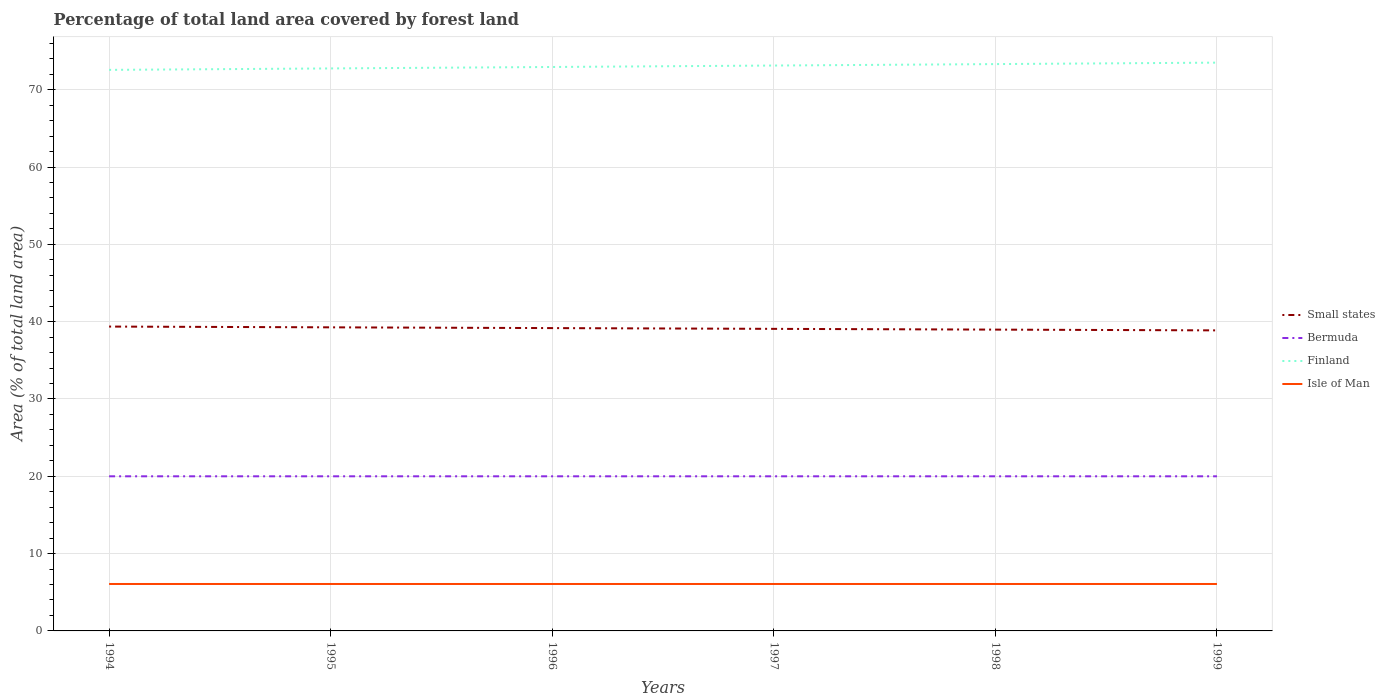How many different coloured lines are there?
Provide a short and direct response. 4. Across all years, what is the maximum percentage of forest land in Finland?
Your answer should be very brief. 72.57. What is the total percentage of forest land in Small states in the graph?
Offer a terse response. 0.1. What is the difference between the highest and the second highest percentage of forest land in Small states?
Provide a succinct answer. 0.49. Is the percentage of forest land in Small states strictly greater than the percentage of forest land in Bermuda over the years?
Make the answer very short. No. Are the values on the major ticks of Y-axis written in scientific E-notation?
Keep it short and to the point. No. Does the graph contain any zero values?
Make the answer very short. No. Does the graph contain grids?
Keep it short and to the point. Yes. Where does the legend appear in the graph?
Ensure brevity in your answer.  Center right. What is the title of the graph?
Your response must be concise. Percentage of total land area covered by forest land. Does "Guam" appear as one of the legend labels in the graph?
Offer a very short reply. No. What is the label or title of the Y-axis?
Offer a very short reply. Area (% of total land area). What is the Area (% of total land area) of Small states in 1994?
Your answer should be very brief. 39.37. What is the Area (% of total land area) in Bermuda in 1994?
Offer a terse response. 20. What is the Area (% of total land area) in Finland in 1994?
Ensure brevity in your answer.  72.57. What is the Area (% of total land area) in Isle of Man in 1994?
Your answer should be compact. 6.07. What is the Area (% of total land area) of Small states in 1995?
Ensure brevity in your answer.  39.27. What is the Area (% of total land area) of Finland in 1995?
Provide a succinct answer. 72.75. What is the Area (% of total land area) of Isle of Man in 1995?
Provide a short and direct response. 6.07. What is the Area (% of total land area) of Small states in 1996?
Make the answer very short. 39.17. What is the Area (% of total land area) of Bermuda in 1996?
Offer a terse response. 20. What is the Area (% of total land area) in Finland in 1996?
Your response must be concise. 72.94. What is the Area (% of total land area) of Isle of Man in 1996?
Give a very brief answer. 6.07. What is the Area (% of total land area) in Small states in 1997?
Provide a short and direct response. 39.07. What is the Area (% of total land area) of Finland in 1997?
Give a very brief answer. 73.13. What is the Area (% of total land area) in Isle of Man in 1997?
Offer a terse response. 6.07. What is the Area (% of total land area) of Small states in 1998?
Your answer should be compact. 38.97. What is the Area (% of total land area) of Bermuda in 1998?
Your answer should be compact. 20. What is the Area (% of total land area) in Finland in 1998?
Provide a short and direct response. 73.31. What is the Area (% of total land area) of Isle of Man in 1998?
Keep it short and to the point. 6.07. What is the Area (% of total land area) in Small states in 1999?
Your answer should be very brief. 38.87. What is the Area (% of total land area) of Finland in 1999?
Offer a terse response. 73.5. What is the Area (% of total land area) in Isle of Man in 1999?
Your answer should be compact. 6.07. Across all years, what is the maximum Area (% of total land area) in Small states?
Make the answer very short. 39.37. Across all years, what is the maximum Area (% of total land area) in Finland?
Make the answer very short. 73.5. Across all years, what is the maximum Area (% of total land area) of Isle of Man?
Give a very brief answer. 6.07. Across all years, what is the minimum Area (% of total land area) in Small states?
Provide a succinct answer. 38.87. Across all years, what is the minimum Area (% of total land area) in Finland?
Your answer should be very brief. 72.57. Across all years, what is the minimum Area (% of total land area) of Isle of Man?
Provide a short and direct response. 6.07. What is the total Area (% of total land area) of Small states in the graph?
Offer a terse response. 234.72. What is the total Area (% of total land area) of Bermuda in the graph?
Provide a succinct answer. 120. What is the total Area (% of total land area) of Finland in the graph?
Your answer should be very brief. 438.21. What is the total Area (% of total land area) of Isle of Man in the graph?
Keep it short and to the point. 36.42. What is the difference between the Area (% of total land area) of Small states in 1994 and that in 1995?
Provide a short and direct response. 0.1. What is the difference between the Area (% of total land area) of Bermuda in 1994 and that in 1995?
Offer a terse response. 0. What is the difference between the Area (% of total land area) in Finland in 1994 and that in 1995?
Give a very brief answer. -0.19. What is the difference between the Area (% of total land area) of Isle of Man in 1994 and that in 1995?
Give a very brief answer. 0. What is the difference between the Area (% of total land area) of Small states in 1994 and that in 1996?
Provide a succinct answer. 0.2. What is the difference between the Area (% of total land area) in Bermuda in 1994 and that in 1996?
Provide a short and direct response. 0. What is the difference between the Area (% of total land area) of Finland in 1994 and that in 1996?
Make the answer very short. -0.37. What is the difference between the Area (% of total land area) in Small states in 1994 and that in 1997?
Your response must be concise. 0.3. What is the difference between the Area (% of total land area) in Finland in 1994 and that in 1997?
Your answer should be compact. -0.56. What is the difference between the Area (% of total land area) in Small states in 1994 and that in 1998?
Your answer should be very brief. 0.39. What is the difference between the Area (% of total land area) of Bermuda in 1994 and that in 1998?
Offer a terse response. 0. What is the difference between the Area (% of total land area) of Finland in 1994 and that in 1998?
Keep it short and to the point. -0.75. What is the difference between the Area (% of total land area) in Small states in 1994 and that in 1999?
Your answer should be very brief. 0.49. What is the difference between the Area (% of total land area) of Finland in 1994 and that in 1999?
Your answer should be very brief. -0.94. What is the difference between the Area (% of total land area) in Isle of Man in 1994 and that in 1999?
Keep it short and to the point. 0. What is the difference between the Area (% of total land area) in Small states in 1995 and that in 1996?
Provide a succinct answer. 0.1. What is the difference between the Area (% of total land area) of Bermuda in 1995 and that in 1996?
Offer a very short reply. 0. What is the difference between the Area (% of total land area) of Finland in 1995 and that in 1996?
Ensure brevity in your answer.  -0.19. What is the difference between the Area (% of total land area) of Small states in 1995 and that in 1997?
Ensure brevity in your answer.  0.2. What is the difference between the Area (% of total land area) of Bermuda in 1995 and that in 1997?
Your answer should be very brief. 0. What is the difference between the Area (% of total land area) in Finland in 1995 and that in 1997?
Offer a very short reply. -0.37. What is the difference between the Area (% of total land area) in Isle of Man in 1995 and that in 1997?
Your response must be concise. 0. What is the difference between the Area (% of total land area) in Small states in 1995 and that in 1998?
Keep it short and to the point. 0.3. What is the difference between the Area (% of total land area) in Finland in 1995 and that in 1998?
Keep it short and to the point. -0.56. What is the difference between the Area (% of total land area) of Small states in 1995 and that in 1999?
Ensure brevity in your answer.  0.39. What is the difference between the Area (% of total land area) of Bermuda in 1995 and that in 1999?
Offer a very short reply. 0. What is the difference between the Area (% of total land area) of Finland in 1995 and that in 1999?
Your response must be concise. -0.75. What is the difference between the Area (% of total land area) of Small states in 1996 and that in 1997?
Provide a succinct answer. 0.1. What is the difference between the Area (% of total land area) of Finland in 1996 and that in 1997?
Provide a short and direct response. -0.19. What is the difference between the Area (% of total land area) in Isle of Man in 1996 and that in 1997?
Provide a succinct answer. 0. What is the difference between the Area (% of total land area) in Small states in 1996 and that in 1998?
Your answer should be compact. 0.2. What is the difference between the Area (% of total land area) in Finland in 1996 and that in 1998?
Provide a short and direct response. -0.37. What is the difference between the Area (% of total land area) of Isle of Man in 1996 and that in 1998?
Make the answer very short. 0. What is the difference between the Area (% of total land area) of Small states in 1996 and that in 1999?
Provide a succinct answer. 0.3. What is the difference between the Area (% of total land area) in Finland in 1996 and that in 1999?
Provide a succinct answer. -0.56. What is the difference between the Area (% of total land area) of Small states in 1997 and that in 1998?
Your answer should be compact. 0.1. What is the difference between the Area (% of total land area) in Bermuda in 1997 and that in 1998?
Your answer should be compact. 0. What is the difference between the Area (% of total land area) in Finland in 1997 and that in 1998?
Ensure brevity in your answer.  -0.19. What is the difference between the Area (% of total land area) of Isle of Man in 1997 and that in 1998?
Provide a short and direct response. 0. What is the difference between the Area (% of total land area) of Small states in 1997 and that in 1999?
Keep it short and to the point. 0.2. What is the difference between the Area (% of total land area) in Finland in 1997 and that in 1999?
Give a very brief answer. -0.37. What is the difference between the Area (% of total land area) in Small states in 1998 and that in 1999?
Your response must be concise. 0.1. What is the difference between the Area (% of total land area) of Bermuda in 1998 and that in 1999?
Offer a terse response. 0. What is the difference between the Area (% of total land area) in Finland in 1998 and that in 1999?
Offer a very short reply. -0.19. What is the difference between the Area (% of total land area) in Isle of Man in 1998 and that in 1999?
Give a very brief answer. 0. What is the difference between the Area (% of total land area) of Small states in 1994 and the Area (% of total land area) of Bermuda in 1995?
Give a very brief answer. 19.37. What is the difference between the Area (% of total land area) of Small states in 1994 and the Area (% of total land area) of Finland in 1995?
Keep it short and to the point. -33.39. What is the difference between the Area (% of total land area) of Small states in 1994 and the Area (% of total land area) of Isle of Man in 1995?
Provide a short and direct response. 33.3. What is the difference between the Area (% of total land area) of Bermuda in 1994 and the Area (% of total land area) of Finland in 1995?
Your response must be concise. -52.75. What is the difference between the Area (% of total land area) of Bermuda in 1994 and the Area (% of total land area) of Isle of Man in 1995?
Ensure brevity in your answer.  13.93. What is the difference between the Area (% of total land area) of Finland in 1994 and the Area (% of total land area) of Isle of Man in 1995?
Provide a short and direct response. 66.5. What is the difference between the Area (% of total land area) of Small states in 1994 and the Area (% of total land area) of Bermuda in 1996?
Provide a succinct answer. 19.37. What is the difference between the Area (% of total land area) of Small states in 1994 and the Area (% of total land area) of Finland in 1996?
Offer a very short reply. -33.58. What is the difference between the Area (% of total land area) in Small states in 1994 and the Area (% of total land area) in Isle of Man in 1996?
Give a very brief answer. 33.3. What is the difference between the Area (% of total land area) of Bermuda in 1994 and the Area (% of total land area) of Finland in 1996?
Provide a succinct answer. -52.94. What is the difference between the Area (% of total land area) in Bermuda in 1994 and the Area (% of total land area) in Isle of Man in 1996?
Offer a terse response. 13.93. What is the difference between the Area (% of total land area) of Finland in 1994 and the Area (% of total land area) of Isle of Man in 1996?
Provide a short and direct response. 66.5. What is the difference between the Area (% of total land area) of Small states in 1994 and the Area (% of total land area) of Bermuda in 1997?
Offer a very short reply. 19.37. What is the difference between the Area (% of total land area) in Small states in 1994 and the Area (% of total land area) in Finland in 1997?
Provide a short and direct response. -33.76. What is the difference between the Area (% of total land area) in Small states in 1994 and the Area (% of total land area) in Isle of Man in 1997?
Provide a succinct answer. 33.3. What is the difference between the Area (% of total land area) of Bermuda in 1994 and the Area (% of total land area) of Finland in 1997?
Make the answer very short. -53.13. What is the difference between the Area (% of total land area) in Bermuda in 1994 and the Area (% of total land area) in Isle of Man in 1997?
Make the answer very short. 13.93. What is the difference between the Area (% of total land area) of Finland in 1994 and the Area (% of total land area) of Isle of Man in 1997?
Provide a succinct answer. 66.5. What is the difference between the Area (% of total land area) in Small states in 1994 and the Area (% of total land area) in Bermuda in 1998?
Your answer should be very brief. 19.37. What is the difference between the Area (% of total land area) of Small states in 1994 and the Area (% of total land area) of Finland in 1998?
Your answer should be very brief. -33.95. What is the difference between the Area (% of total land area) in Small states in 1994 and the Area (% of total land area) in Isle of Man in 1998?
Make the answer very short. 33.3. What is the difference between the Area (% of total land area) in Bermuda in 1994 and the Area (% of total land area) in Finland in 1998?
Offer a terse response. -53.31. What is the difference between the Area (% of total land area) in Bermuda in 1994 and the Area (% of total land area) in Isle of Man in 1998?
Your response must be concise. 13.93. What is the difference between the Area (% of total land area) of Finland in 1994 and the Area (% of total land area) of Isle of Man in 1998?
Provide a short and direct response. 66.5. What is the difference between the Area (% of total land area) in Small states in 1994 and the Area (% of total land area) in Bermuda in 1999?
Make the answer very short. 19.37. What is the difference between the Area (% of total land area) of Small states in 1994 and the Area (% of total land area) of Finland in 1999?
Offer a very short reply. -34.14. What is the difference between the Area (% of total land area) of Small states in 1994 and the Area (% of total land area) of Isle of Man in 1999?
Your answer should be very brief. 33.3. What is the difference between the Area (% of total land area) in Bermuda in 1994 and the Area (% of total land area) in Finland in 1999?
Offer a terse response. -53.5. What is the difference between the Area (% of total land area) in Bermuda in 1994 and the Area (% of total land area) in Isle of Man in 1999?
Make the answer very short. 13.93. What is the difference between the Area (% of total land area) of Finland in 1994 and the Area (% of total land area) of Isle of Man in 1999?
Offer a very short reply. 66.5. What is the difference between the Area (% of total land area) in Small states in 1995 and the Area (% of total land area) in Bermuda in 1996?
Provide a succinct answer. 19.27. What is the difference between the Area (% of total land area) of Small states in 1995 and the Area (% of total land area) of Finland in 1996?
Make the answer very short. -33.67. What is the difference between the Area (% of total land area) in Small states in 1995 and the Area (% of total land area) in Isle of Man in 1996?
Your answer should be compact. 33.2. What is the difference between the Area (% of total land area) in Bermuda in 1995 and the Area (% of total land area) in Finland in 1996?
Your response must be concise. -52.94. What is the difference between the Area (% of total land area) in Bermuda in 1995 and the Area (% of total land area) in Isle of Man in 1996?
Your response must be concise. 13.93. What is the difference between the Area (% of total land area) in Finland in 1995 and the Area (% of total land area) in Isle of Man in 1996?
Make the answer very short. 66.68. What is the difference between the Area (% of total land area) in Small states in 1995 and the Area (% of total land area) in Bermuda in 1997?
Your answer should be compact. 19.27. What is the difference between the Area (% of total land area) in Small states in 1995 and the Area (% of total land area) in Finland in 1997?
Make the answer very short. -33.86. What is the difference between the Area (% of total land area) in Small states in 1995 and the Area (% of total land area) in Isle of Man in 1997?
Give a very brief answer. 33.2. What is the difference between the Area (% of total land area) of Bermuda in 1995 and the Area (% of total land area) of Finland in 1997?
Provide a short and direct response. -53.13. What is the difference between the Area (% of total land area) of Bermuda in 1995 and the Area (% of total land area) of Isle of Man in 1997?
Ensure brevity in your answer.  13.93. What is the difference between the Area (% of total land area) in Finland in 1995 and the Area (% of total land area) in Isle of Man in 1997?
Make the answer very short. 66.68. What is the difference between the Area (% of total land area) in Small states in 1995 and the Area (% of total land area) in Bermuda in 1998?
Ensure brevity in your answer.  19.27. What is the difference between the Area (% of total land area) in Small states in 1995 and the Area (% of total land area) in Finland in 1998?
Give a very brief answer. -34.05. What is the difference between the Area (% of total land area) of Small states in 1995 and the Area (% of total land area) of Isle of Man in 1998?
Provide a short and direct response. 33.2. What is the difference between the Area (% of total land area) in Bermuda in 1995 and the Area (% of total land area) in Finland in 1998?
Give a very brief answer. -53.31. What is the difference between the Area (% of total land area) of Bermuda in 1995 and the Area (% of total land area) of Isle of Man in 1998?
Keep it short and to the point. 13.93. What is the difference between the Area (% of total land area) in Finland in 1995 and the Area (% of total land area) in Isle of Man in 1998?
Your answer should be compact. 66.68. What is the difference between the Area (% of total land area) of Small states in 1995 and the Area (% of total land area) of Bermuda in 1999?
Make the answer very short. 19.27. What is the difference between the Area (% of total land area) of Small states in 1995 and the Area (% of total land area) of Finland in 1999?
Your response must be concise. -34.24. What is the difference between the Area (% of total land area) in Small states in 1995 and the Area (% of total land area) in Isle of Man in 1999?
Offer a very short reply. 33.2. What is the difference between the Area (% of total land area) of Bermuda in 1995 and the Area (% of total land area) of Finland in 1999?
Offer a terse response. -53.5. What is the difference between the Area (% of total land area) of Bermuda in 1995 and the Area (% of total land area) of Isle of Man in 1999?
Keep it short and to the point. 13.93. What is the difference between the Area (% of total land area) in Finland in 1995 and the Area (% of total land area) in Isle of Man in 1999?
Ensure brevity in your answer.  66.68. What is the difference between the Area (% of total land area) in Small states in 1996 and the Area (% of total land area) in Bermuda in 1997?
Provide a short and direct response. 19.17. What is the difference between the Area (% of total land area) in Small states in 1996 and the Area (% of total land area) in Finland in 1997?
Offer a very short reply. -33.96. What is the difference between the Area (% of total land area) of Small states in 1996 and the Area (% of total land area) of Isle of Man in 1997?
Your answer should be compact. 33.1. What is the difference between the Area (% of total land area) in Bermuda in 1996 and the Area (% of total land area) in Finland in 1997?
Offer a very short reply. -53.13. What is the difference between the Area (% of total land area) in Bermuda in 1996 and the Area (% of total land area) in Isle of Man in 1997?
Your answer should be very brief. 13.93. What is the difference between the Area (% of total land area) in Finland in 1996 and the Area (% of total land area) in Isle of Man in 1997?
Give a very brief answer. 66.87. What is the difference between the Area (% of total land area) in Small states in 1996 and the Area (% of total land area) in Bermuda in 1998?
Offer a terse response. 19.17. What is the difference between the Area (% of total land area) in Small states in 1996 and the Area (% of total land area) in Finland in 1998?
Offer a terse response. -34.15. What is the difference between the Area (% of total land area) of Small states in 1996 and the Area (% of total land area) of Isle of Man in 1998?
Your response must be concise. 33.1. What is the difference between the Area (% of total land area) of Bermuda in 1996 and the Area (% of total land area) of Finland in 1998?
Your answer should be compact. -53.31. What is the difference between the Area (% of total land area) of Bermuda in 1996 and the Area (% of total land area) of Isle of Man in 1998?
Make the answer very short. 13.93. What is the difference between the Area (% of total land area) of Finland in 1996 and the Area (% of total land area) of Isle of Man in 1998?
Ensure brevity in your answer.  66.87. What is the difference between the Area (% of total land area) in Small states in 1996 and the Area (% of total land area) in Bermuda in 1999?
Make the answer very short. 19.17. What is the difference between the Area (% of total land area) in Small states in 1996 and the Area (% of total land area) in Finland in 1999?
Offer a very short reply. -34.33. What is the difference between the Area (% of total land area) of Small states in 1996 and the Area (% of total land area) of Isle of Man in 1999?
Offer a very short reply. 33.1. What is the difference between the Area (% of total land area) in Bermuda in 1996 and the Area (% of total land area) in Finland in 1999?
Ensure brevity in your answer.  -53.5. What is the difference between the Area (% of total land area) in Bermuda in 1996 and the Area (% of total land area) in Isle of Man in 1999?
Your response must be concise. 13.93. What is the difference between the Area (% of total land area) in Finland in 1996 and the Area (% of total land area) in Isle of Man in 1999?
Your answer should be very brief. 66.87. What is the difference between the Area (% of total land area) in Small states in 1997 and the Area (% of total land area) in Bermuda in 1998?
Provide a short and direct response. 19.07. What is the difference between the Area (% of total land area) in Small states in 1997 and the Area (% of total land area) in Finland in 1998?
Give a very brief answer. -34.24. What is the difference between the Area (% of total land area) of Small states in 1997 and the Area (% of total land area) of Isle of Man in 1998?
Make the answer very short. 33. What is the difference between the Area (% of total land area) in Bermuda in 1997 and the Area (% of total land area) in Finland in 1998?
Provide a short and direct response. -53.31. What is the difference between the Area (% of total land area) in Bermuda in 1997 and the Area (% of total land area) in Isle of Man in 1998?
Your answer should be compact. 13.93. What is the difference between the Area (% of total land area) in Finland in 1997 and the Area (% of total land area) in Isle of Man in 1998?
Your answer should be compact. 67.06. What is the difference between the Area (% of total land area) of Small states in 1997 and the Area (% of total land area) of Bermuda in 1999?
Offer a very short reply. 19.07. What is the difference between the Area (% of total land area) in Small states in 1997 and the Area (% of total land area) in Finland in 1999?
Offer a terse response. -34.43. What is the difference between the Area (% of total land area) in Small states in 1997 and the Area (% of total land area) in Isle of Man in 1999?
Your answer should be very brief. 33. What is the difference between the Area (% of total land area) in Bermuda in 1997 and the Area (% of total land area) in Finland in 1999?
Your answer should be compact. -53.5. What is the difference between the Area (% of total land area) in Bermuda in 1997 and the Area (% of total land area) in Isle of Man in 1999?
Your answer should be very brief. 13.93. What is the difference between the Area (% of total land area) of Finland in 1997 and the Area (% of total land area) of Isle of Man in 1999?
Offer a very short reply. 67.06. What is the difference between the Area (% of total land area) in Small states in 1998 and the Area (% of total land area) in Bermuda in 1999?
Offer a very short reply. 18.97. What is the difference between the Area (% of total land area) in Small states in 1998 and the Area (% of total land area) in Finland in 1999?
Your answer should be very brief. -34.53. What is the difference between the Area (% of total land area) in Small states in 1998 and the Area (% of total land area) in Isle of Man in 1999?
Provide a succinct answer. 32.9. What is the difference between the Area (% of total land area) in Bermuda in 1998 and the Area (% of total land area) in Finland in 1999?
Provide a succinct answer. -53.5. What is the difference between the Area (% of total land area) of Bermuda in 1998 and the Area (% of total land area) of Isle of Man in 1999?
Keep it short and to the point. 13.93. What is the difference between the Area (% of total land area) of Finland in 1998 and the Area (% of total land area) of Isle of Man in 1999?
Your answer should be very brief. 67.24. What is the average Area (% of total land area) in Small states per year?
Ensure brevity in your answer.  39.12. What is the average Area (% of total land area) in Finland per year?
Your answer should be very brief. 73.03. What is the average Area (% of total land area) in Isle of Man per year?
Ensure brevity in your answer.  6.07. In the year 1994, what is the difference between the Area (% of total land area) in Small states and Area (% of total land area) in Bermuda?
Make the answer very short. 19.37. In the year 1994, what is the difference between the Area (% of total land area) of Small states and Area (% of total land area) of Finland?
Give a very brief answer. -33.2. In the year 1994, what is the difference between the Area (% of total land area) of Small states and Area (% of total land area) of Isle of Man?
Offer a terse response. 33.3. In the year 1994, what is the difference between the Area (% of total land area) in Bermuda and Area (% of total land area) in Finland?
Provide a short and direct response. -52.57. In the year 1994, what is the difference between the Area (% of total land area) in Bermuda and Area (% of total land area) in Isle of Man?
Provide a short and direct response. 13.93. In the year 1994, what is the difference between the Area (% of total land area) of Finland and Area (% of total land area) of Isle of Man?
Give a very brief answer. 66.5. In the year 1995, what is the difference between the Area (% of total land area) of Small states and Area (% of total land area) of Bermuda?
Your answer should be compact. 19.27. In the year 1995, what is the difference between the Area (% of total land area) in Small states and Area (% of total land area) in Finland?
Provide a succinct answer. -33.49. In the year 1995, what is the difference between the Area (% of total land area) in Small states and Area (% of total land area) in Isle of Man?
Keep it short and to the point. 33.2. In the year 1995, what is the difference between the Area (% of total land area) in Bermuda and Area (% of total land area) in Finland?
Your answer should be very brief. -52.75. In the year 1995, what is the difference between the Area (% of total land area) in Bermuda and Area (% of total land area) in Isle of Man?
Give a very brief answer. 13.93. In the year 1995, what is the difference between the Area (% of total land area) of Finland and Area (% of total land area) of Isle of Man?
Make the answer very short. 66.68. In the year 1996, what is the difference between the Area (% of total land area) of Small states and Area (% of total land area) of Bermuda?
Your answer should be very brief. 19.17. In the year 1996, what is the difference between the Area (% of total land area) in Small states and Area (% of total land area) in Finland?
Offer a very short reply. -33.77. In the year 1996, what is the difference between the Area (% of total land area) of Small states and Area (% of total land area) of Isle of Man?
Ensure brevity in your answer.  33.1. In the year 1996, what is the difference between the Area (% of total land area) of Bermuda and Area (% of total land area) of Finland?
Offer a very short reply. -52.94. In the year 1996, what is the difference between the Area (% of total land area) of Bermuda and Area (% of total land area) of Isle of Man?
Provide a short and direct response. 13.93. In the year 1996, what is the difference between the Area (% of total land area) in Finland and Area (% of total land area) in Isle of Man?
Your answer should be very brief. 66.87. In the year 1997, what is the difference between the Area (% of total land area) of Small states and Area (% of total land area) of Bermuda?
Your answer should be compact. 19.07. In the year 1997, what is the difference between the Area (% of total land area) of Small states and Area (% of total land area) of Finland?
Your response must be concise. -34.06. In the year 1997, what is the difference between the Area (% of total land area) of Small states and Area (% of total land area) of Isle of Man?
Your response must be concise. 33. In the year 1997, what is the difference between the Area (% of total land area) of Bermuda and Area (% of total land area) of Finland?
Ensure brevity in your answer.  -53.13. In the year 1997, what is the difference between the Area (% of total land area) in Bermuda and Area (% of total land area) in Isle of Man?
Keep it short and to the point. 13.93. In the year 1997, what is the difference between the Area (% of total land area) in Finland and Area (% of total land area) in Isle of Man?
Provide a short and direct response. 67.06. In the year 1998, what is the difference between the Area (% of total land area) in Small states and Area (% of total land area) in Bermuda?
Ensure brevity in your answer.  18.97. In the year 1998, what is the difference between the Area (% of total land area) in Small states and Area (% of total land area) in Finland?
Offer a terse response. -34.34. In the year 1998, what is the difference between the Area (% of total land area) in Small states and Area (% of total land area) in Isle of Man?
Keep it short and to the point. 32.9. In the year 1998, what is the difference between the Area (% of total land area) of Bermuda and Area (% of total land area) of Finland?
Offer a terse response. -53.31. In the year 1998, what is the difference between the Area (% of total land area) of Bermuda and Area (% of total land area) of Isle of Man?
Make the answer very short. 13.93. In the year 1998, what is the difference between the Area (% of total land area) in Finland and Area (% of total land area) in Isle of Man?
Ensure brevity in your answer.  67.24. In the year 1999, what is the difference between the Area (% of total land area) in Small states and Area (% of total land area) in Bermuda?
Offer a terse response. 18.87. In the year 1999, what is the difference between the Area (% of total land area) in Small states and Area (% of total land area) in Finland?
Make the answer very short. -34.63. In the year 1999, what is the difference between the Area (% of total land area) of Small states and Area (% of total land area) of Isle of Man?
Provide a succinct answer. 32.8. In the year 1999, what is the difference between the Area (% of total land area) in Bermuda and Area (% of total land area) in Finland?
Offer a terse response. -53.5. In the year 1999, what is the difference between the Area (% of total land area) in Bermuda and Area (% of total land area) in Isle of Man?
Your answer should be compact. 13.93. In the year 1999, what is the difference between the Area (% of total land area) of Finland and Area (% of total land area) of Isle of Man?
Your answer should be compact. 67.43. What is the ratio of the Area (% of total land area) of Small states in 1994 to that in 1995?
Make the answer very short. 1. What is the ratio of the Area (% of total land area) in Bermuda in 1994 to that in 1995?
Provide a short and direct response. 1. What is the ratio of the Area (% of total land area) of Small states in 1994 to that in 1997?
Provide a short and direct response. 1.01. What is the ratio of the Area (% of total land area) of Bermuda in 1994 to that in 1998?
Provide a succinct answer. 1. What is the ratio of the Area (% of total land area) of Finland in 1994 to that in 1998?
Ensure brevity in your answer.  0.99. What is the ratio of the Area (% of total land area) in Small states in 1994 to that in 1999?
Keep it short and to the point. 1.01. What is the ratio of the Area (% of total land area) of Finland in 1994 to that in 1999?
Your answer should be compact. 0.99. What is the ratio of the Area (% of total land area) in Small states in 1995 to that in 1996?
Your answer should be very brief. 1. What is the ratio of the Area (% of total land area) of Isle of Man in 1995 to that in 1996?
Provide a short and direct response. 1. What is the ratio of the Area (% of total land area) in Bermuda in 1995 to that in 1997?
Offer a terse response. 1. What is the ratio of the Area (% of total land area) of Small states in 1995 to that in 1998?
Offer a terse response. 1.01. What is the ratio of the Area (% of total land area) in Bermuda in 1995 to that in 1998?
Provide a short and direct response. 1. What is the ratio of the Area (% of total land area) of Isle of Man in 1995 to that in 1998?
Offer a terse response. 1. What is the ratio of the Area (% of total land area) in Small states in 1995 to that in 1999?
Your response must be concise. 1.01. What is the ratio of the Area (% of total land area) of Bermuda in 1995 to that in 1999?
Give a very brief answer. 1. What is the ratio of the Area (% of total land area) in Finland in 1995 to that in 1999?
Provide a succinct answer. 0.99. What is the ratio of the Area (% of total land area) in Isle of Man in 1995 to that in 1999?
Your answer should be very brief. 1. What is the ratio of the Area (% of total land area) in Bermuda in 1996 to that in 1997?
Make the answer very short. 1. What is the ratio of the Area (% of total land area) of Finland in 1996 to that in 1997?
Keep it short and to the point. 1. What is the ratio of the Area (% of total land area) of Small states in 1996 to that in 1998?
Provide a short and direct response. 1.01. What is the ratio of the Area (% of total land area) in Bermuda in 1996 to that in 1998?
Your answer should be very brief. 1. What is the ratio of the Area (% of total land area) in Small states in 1996 to that in 1999?
Provide a short and direct response. 1.01. What is the ratio of the Area (% of total land area) of Finland in 1996 to that in 1999?
Offer a very short reply. 0.99. What is the ratio of the Area (% of total land area) in Isle of Man in 1996 to that in 1999?
Your answer should be very brief. 1. What is the ratio of the Area (% of total land area) in Small states in 1997 to that in 1998?
Provide a short and direct response. 1. What is the ratio of the Area (% of total land area) of Bermuda in 1997 to that in 1998?
Provide a succinct answer. 1. What is the ratio of the Area (% of total land area) of Bermuda in 1997 to that in 1999?
Offer a very short reply. 1. What is the ratio of the Area (% of total land area) of Finland in 1997 to that in 1999?
Offer a very short reply. 0.99. What is the ratio of the Area (% of total land area) of Small states in 1998 to that in 1999?
Keep it short and to the point. 1. What is the ratio of the Area (% of total land area) of Bermuda in 1998 to that in 1999?
Give a very brief answer. 1. What is the difference between the highest and the second highest Area (% of total land area) in Small states?
Offer a terse response. 0.1. What is the difference between the highest and the second highest Area (% of total land area) of Finland?
Make the answer very short. 0.19. What is the difference between the highest and the second highest Area (% of total land area) in Isle of Man?
Provide a succinct answer. 0. What is the difference between the highest and the lowest Area (% of total land area) in Small states?
Provide a short and direct response. 0.49. What is the difference between the highest and the lowest Area (% of total land area) of Bermuda?
Provide a succinct answer. 0. What is the difference between the highest and the lowest Area (% of total land area) of Finland?
Offer a terse response. 0.94. What is the difference between the highest and the lowest Area (% of total land area) in Isle of Man?
Provide a short and direct response. 0. 